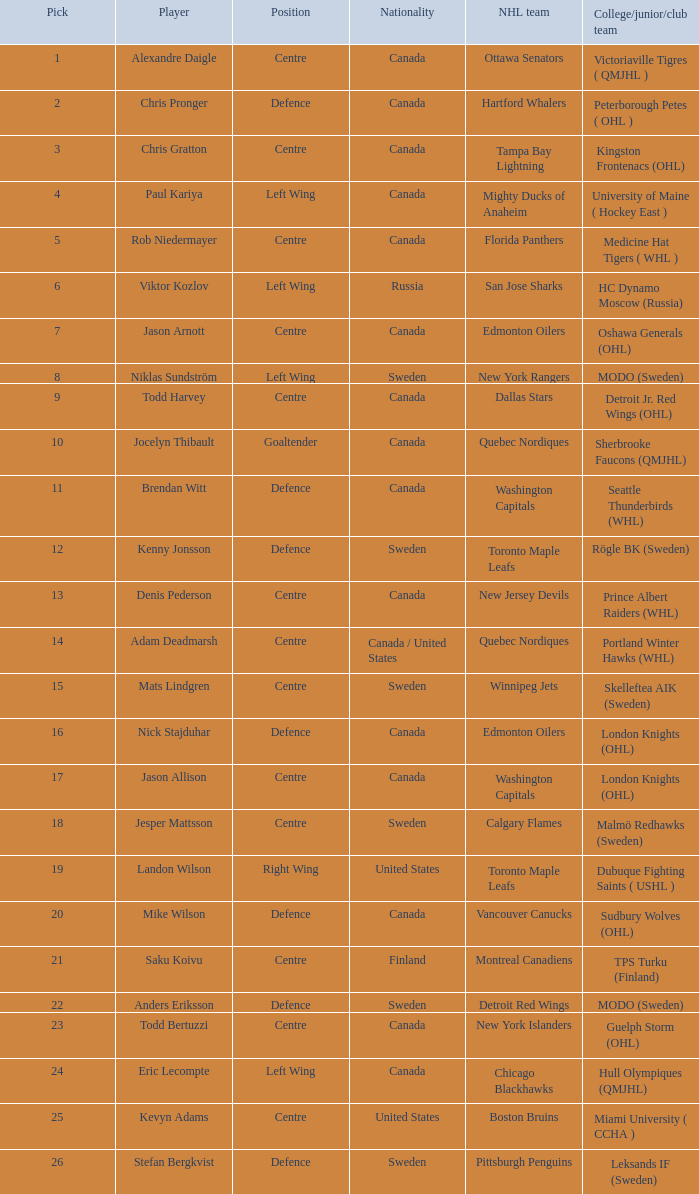How many NHL teams is Denis Pederson a draft pick for? 1.0. 